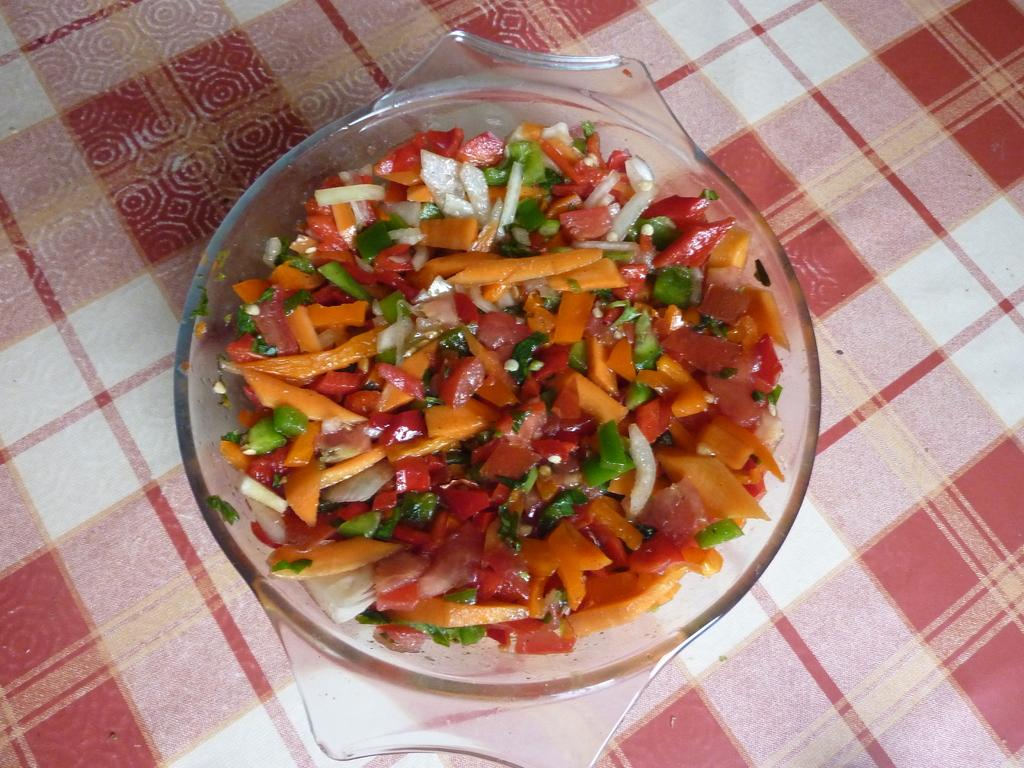What is in the bowl that is visible in the image? There is a salad in a bowl in the image. Where is the bowl located in the image? The bowl is placed on a table. What type of steel is used to make the garden in the image? There is no steel or garden present in the image; it features a bowl of salad on a table. 